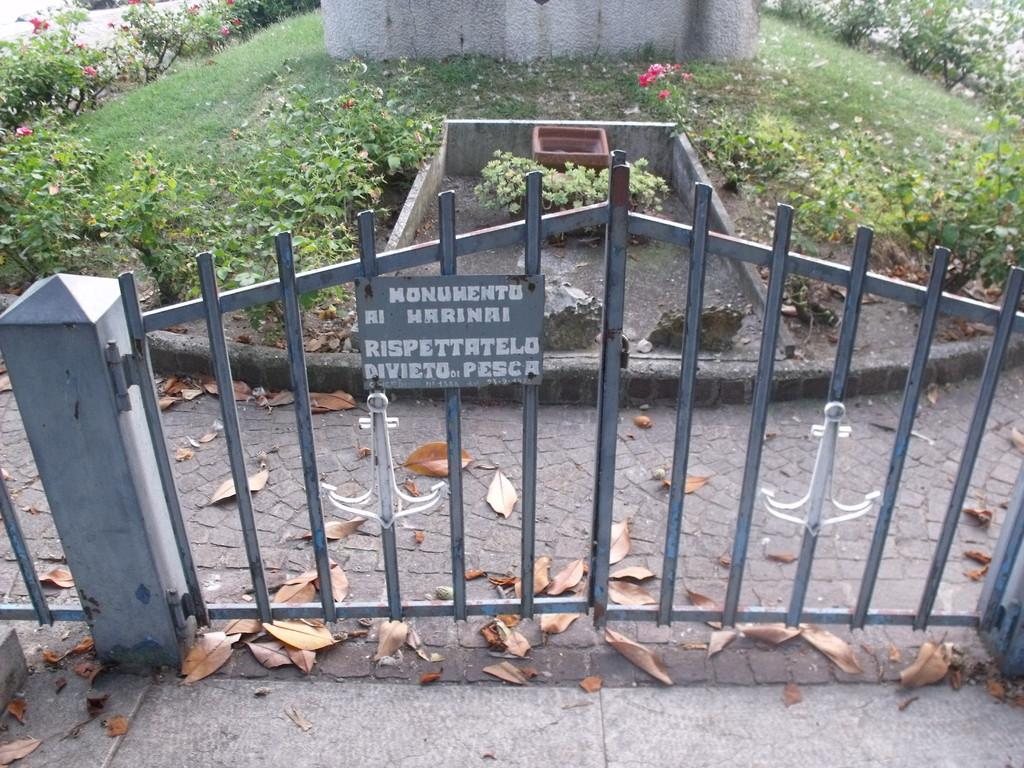What type of structure is present in the image? There is an iron gate in the image. What can be seen in the background of the image? There are green color plants in the background of the image. What type of acoustics can be heard coming from the pail in the image? There is no pail present in the image, so it's not possible to determine the acoustics. 